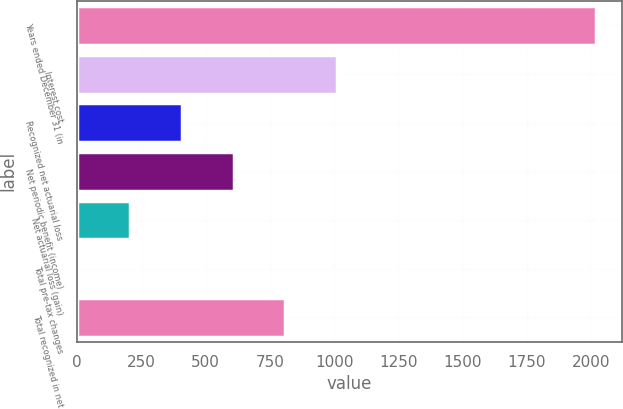Convert chart. <chart><loc_0><loc_0><loc_500><loc_500><bar_chart><fcel>Years ended December 31 (in<fcel>Interest cost<fcel>Recognized net actuarial loss<fcel>Net periodic benefit (income)<fcel>Net actuarial loss (gain)<fcel>Total pre-tax changes<fcel>Total recognized in net<nl><fcel>2017<fcel>1010.5<fcel>406.6<fcel>607.9<fcel>205.3<fcel>4<fcel>809.2<nl></chart> 